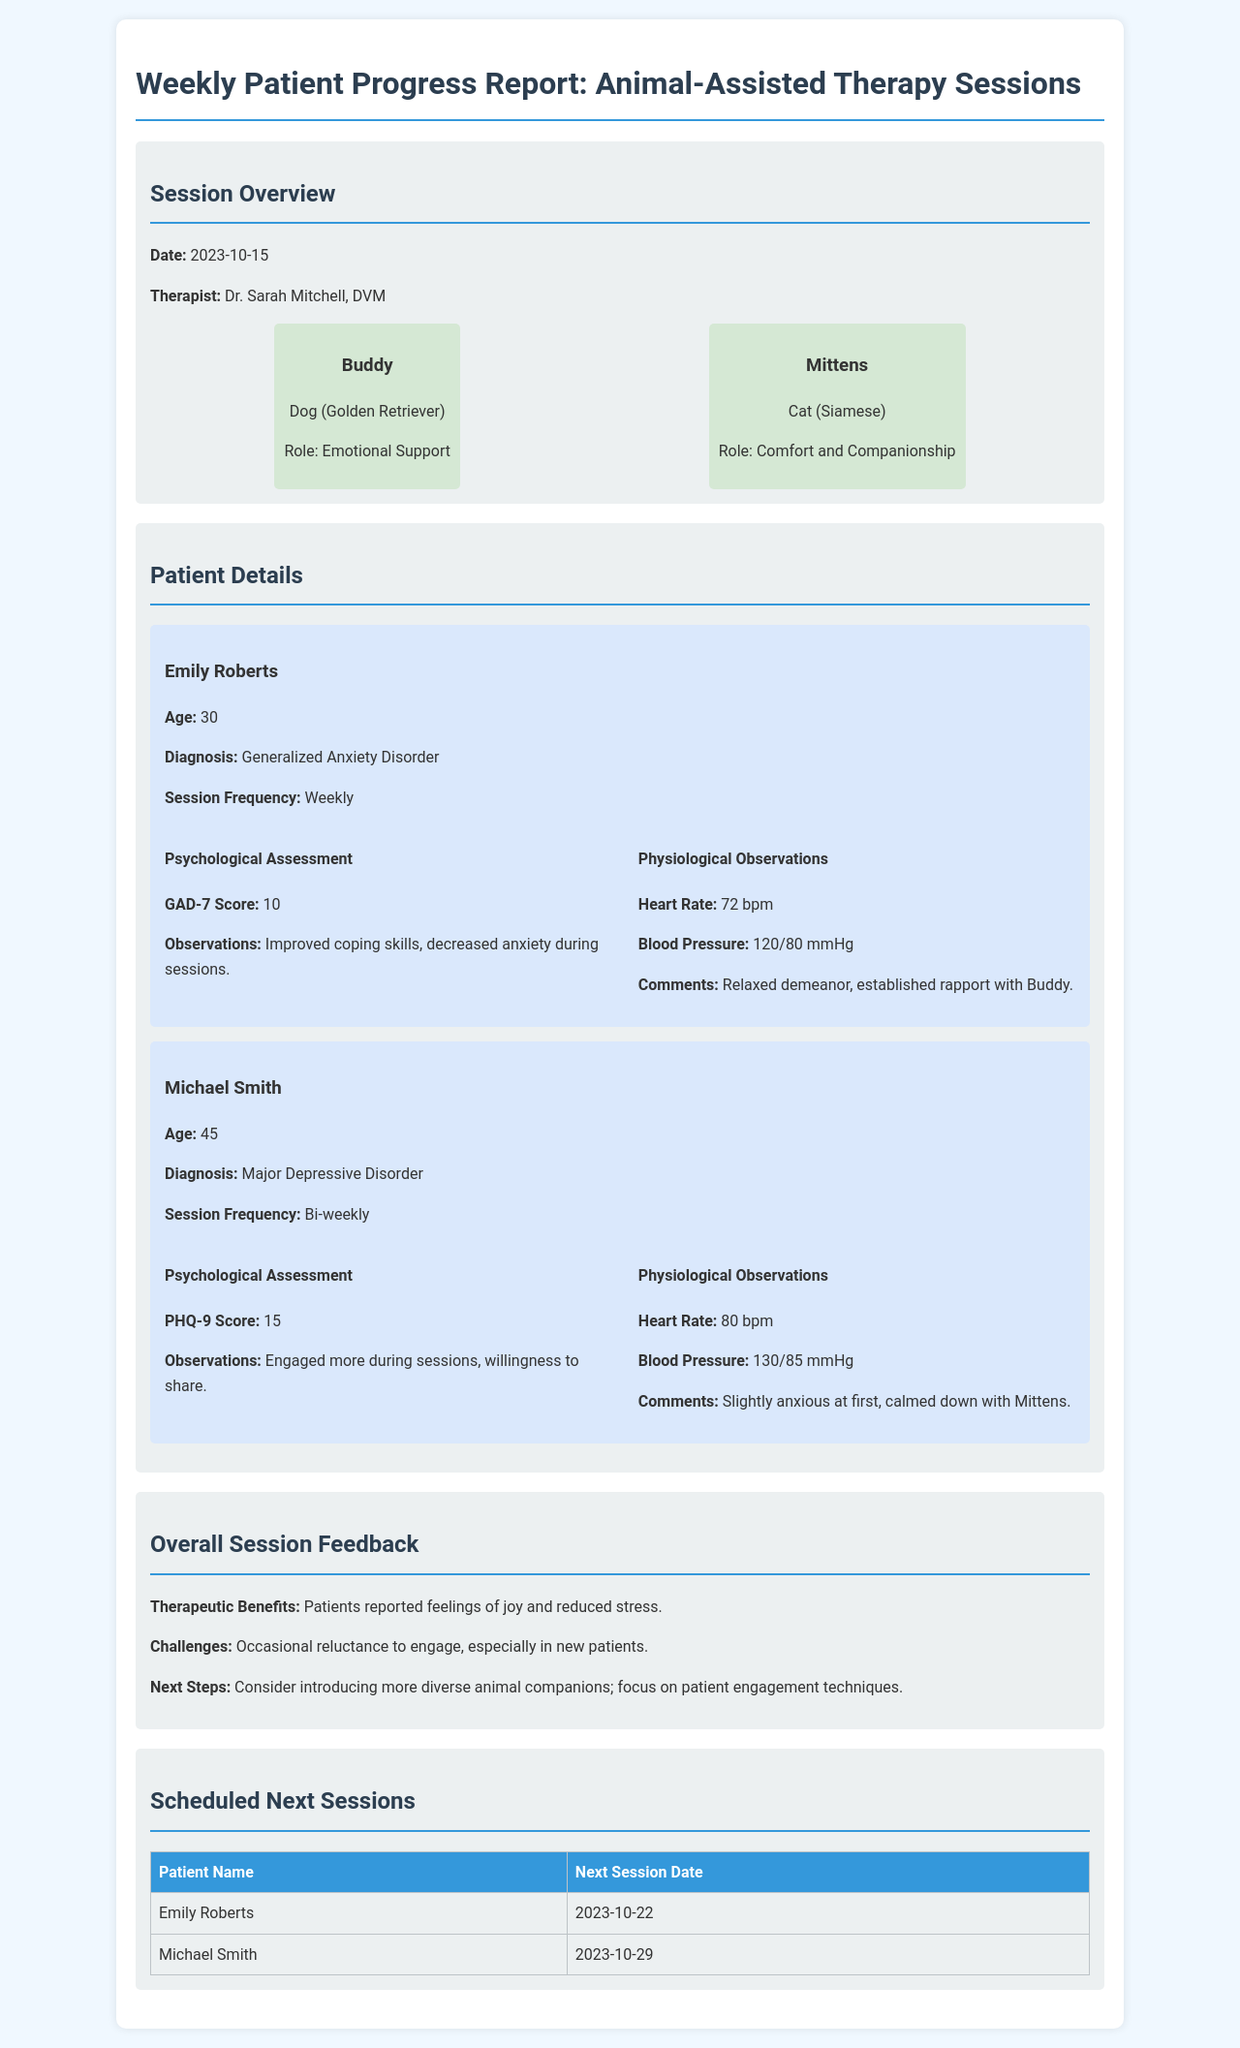what is the date of the report? The report's date is stated in the session overview.
Answer: 2023-10-15 who is the therapist? The therapist's name is mentioned in the session overview.
Answer: Dr. Sarah Mitchell, DVM what is Emily Roberts' GAD-7 score? The GAD-7 score for Emily Roberts is detailed in her psychological assessment.
Answer: 10 how often does Michael Smith have sessions? The session frequency for Michael Smith is provided in his details.
Answer: Bi-weekly what role does Buddy play in therapy? Buddy's role is listed in the animal assistants section.
Answer: Emotional Support what physiological observation was noted for Emily Roberts? A specific physiological observation for Emily Roberts is found in her details.
Answer: Relaxed demeanor, established rapport with Buddy what is the next session date for Michael Smith? The next session date for Michael Smith is listed in the next sessions section.
Answer: 2023-10-29 what therapeutic benefits were reported in the overall session feedback? The therapeutic benefits are mentioned in the overall session feedback section.
Answer: Feelings of joy and reduced stress what was noted as a challenge in the session feedback? The challenges faced are outlined in the overall session feedback.
Answer: Occasional reluctance to engage, especially in new patients which animal was mentioned as providing comfort and companionship? The specific animal type that provides comfort is outlined in the animal assistants section.
Answer: Mittens 